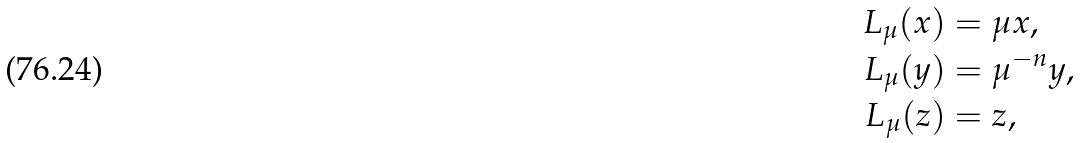Convert formula to latex. <formula><loc_0><loc_0><loc_500><loc_500>L _ { \mu } ( x ) & = \mu x , \\ L _ { \mu } ( y ) & = \mu ^ { - n } y , \\ L _ { \mu } ( z ) & = z ,</formula> 